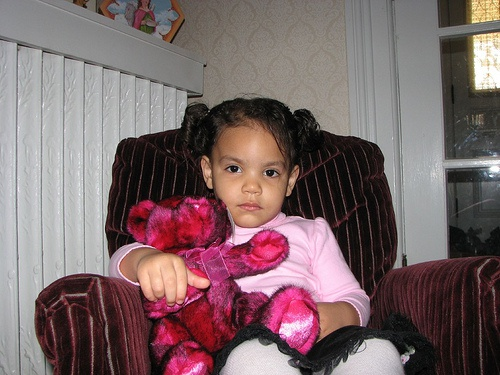Describe the objects in this image and their specific colors. I can see chair in gray, black, maroon, pink, and brown tones and teddy bear in gray, maroon, brown, and black tones in this image. 